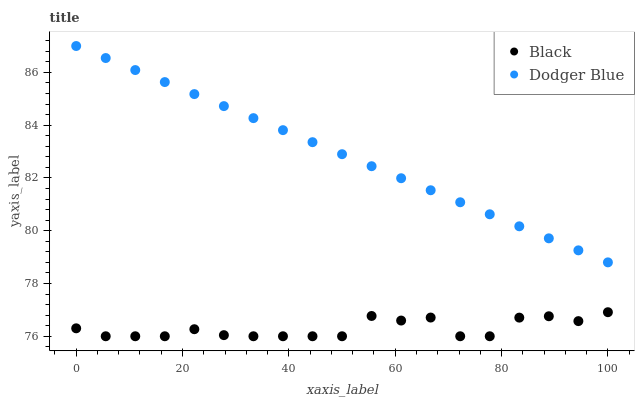Does Black have the minimum area under the curve?
Answer yes or no. Yes. Does Dodger Blue have the maximum area under the curve?
Answer yes or no. Yes. Does Black have the maximum area under the curve?
Answer yes or no. No. Is Dodger Blue the smoothest?
Answer yes or no. Yes. Is Black the roughest?
Answer yes or no. Yes. Is Black the smoothest?
Answer yes or no. No. Does Black have the lowest value?
Answer yes or no. Yes. Does Dodger Blue have the highest value?
Answer yes or no. Yes. Does Black have the highest value?
Answer yes or no. No. Is Black less than Dodger Blue?
Answer yes or no. Yes. Is Dodger Blue greater than Black?
Answer yes or no. Yes. Does Black intersect Dodger Blue?
Answer yes or no. No. 